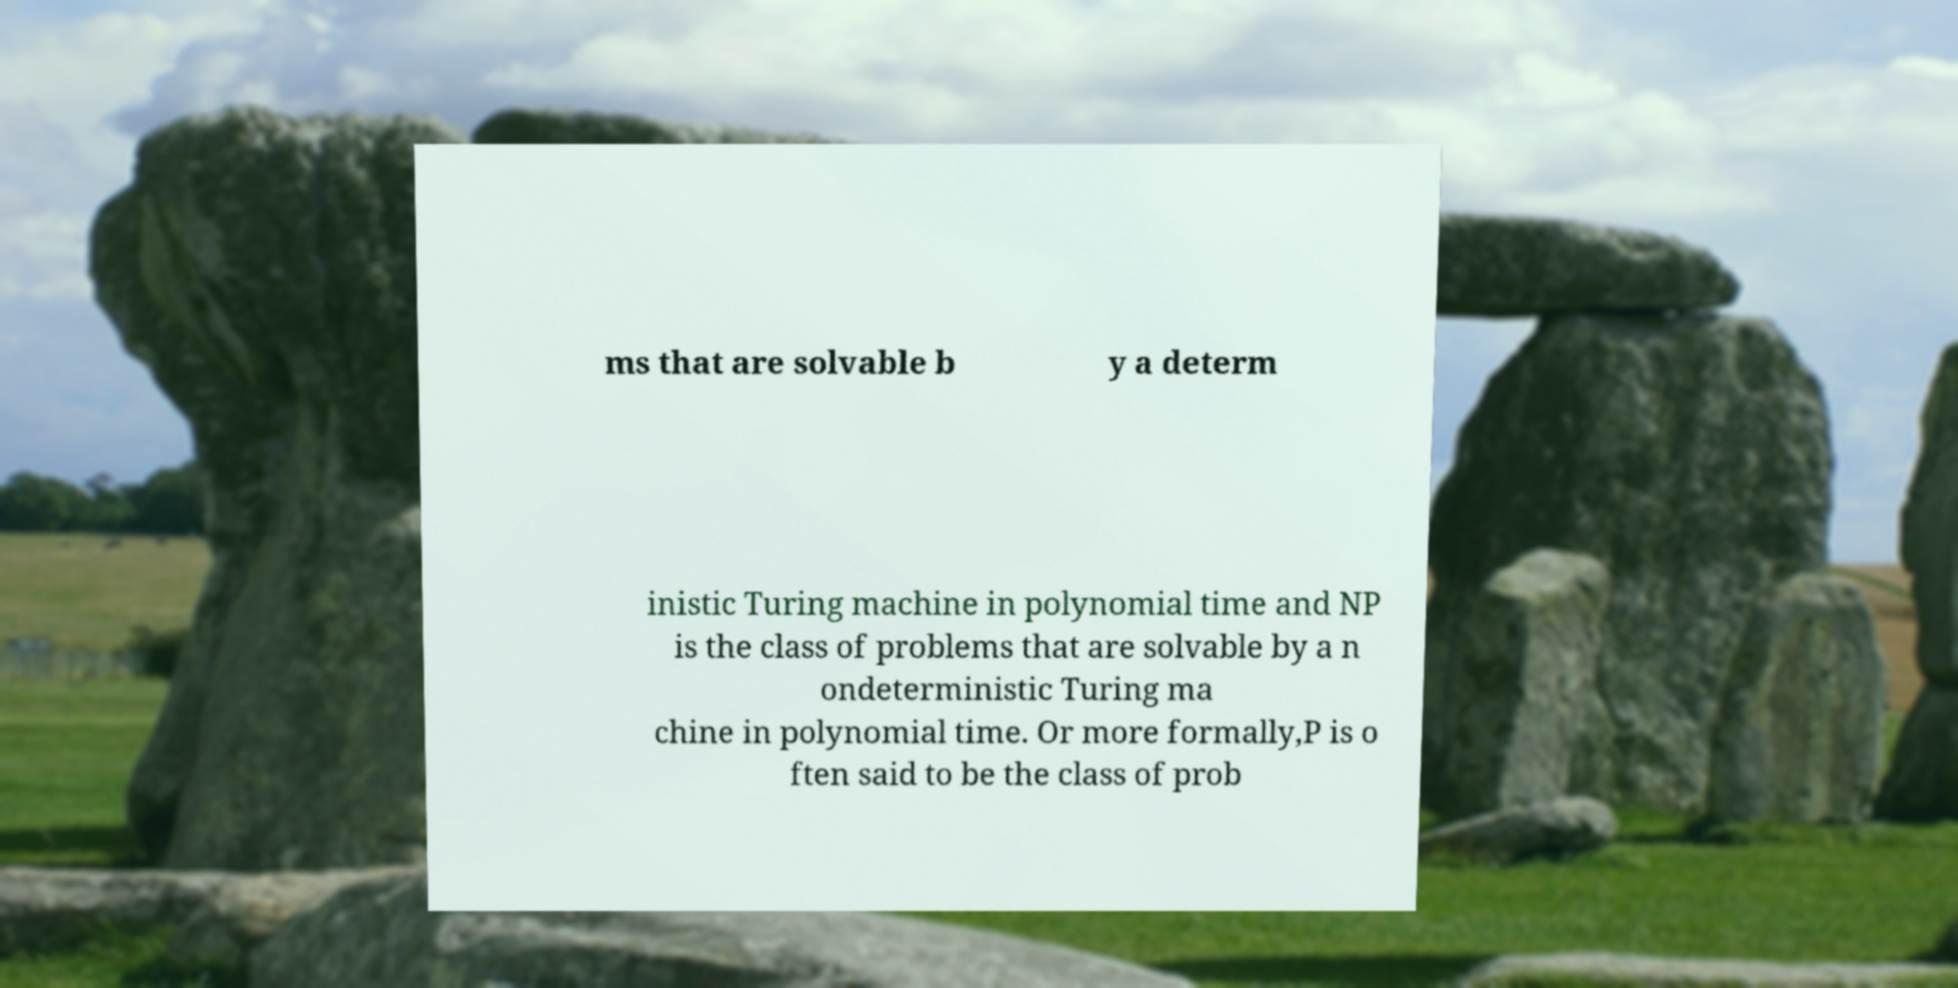What messages or text are displayed in this image? I need them in a readable, typed format. ms that are solvable b y a determ inistic Turing machine in polynomial time and NP is the class of problems that are solvable by a n ondeterministic Turing ma chine in polynomial time. Or more formally,P is o ften said to be the class of prob 